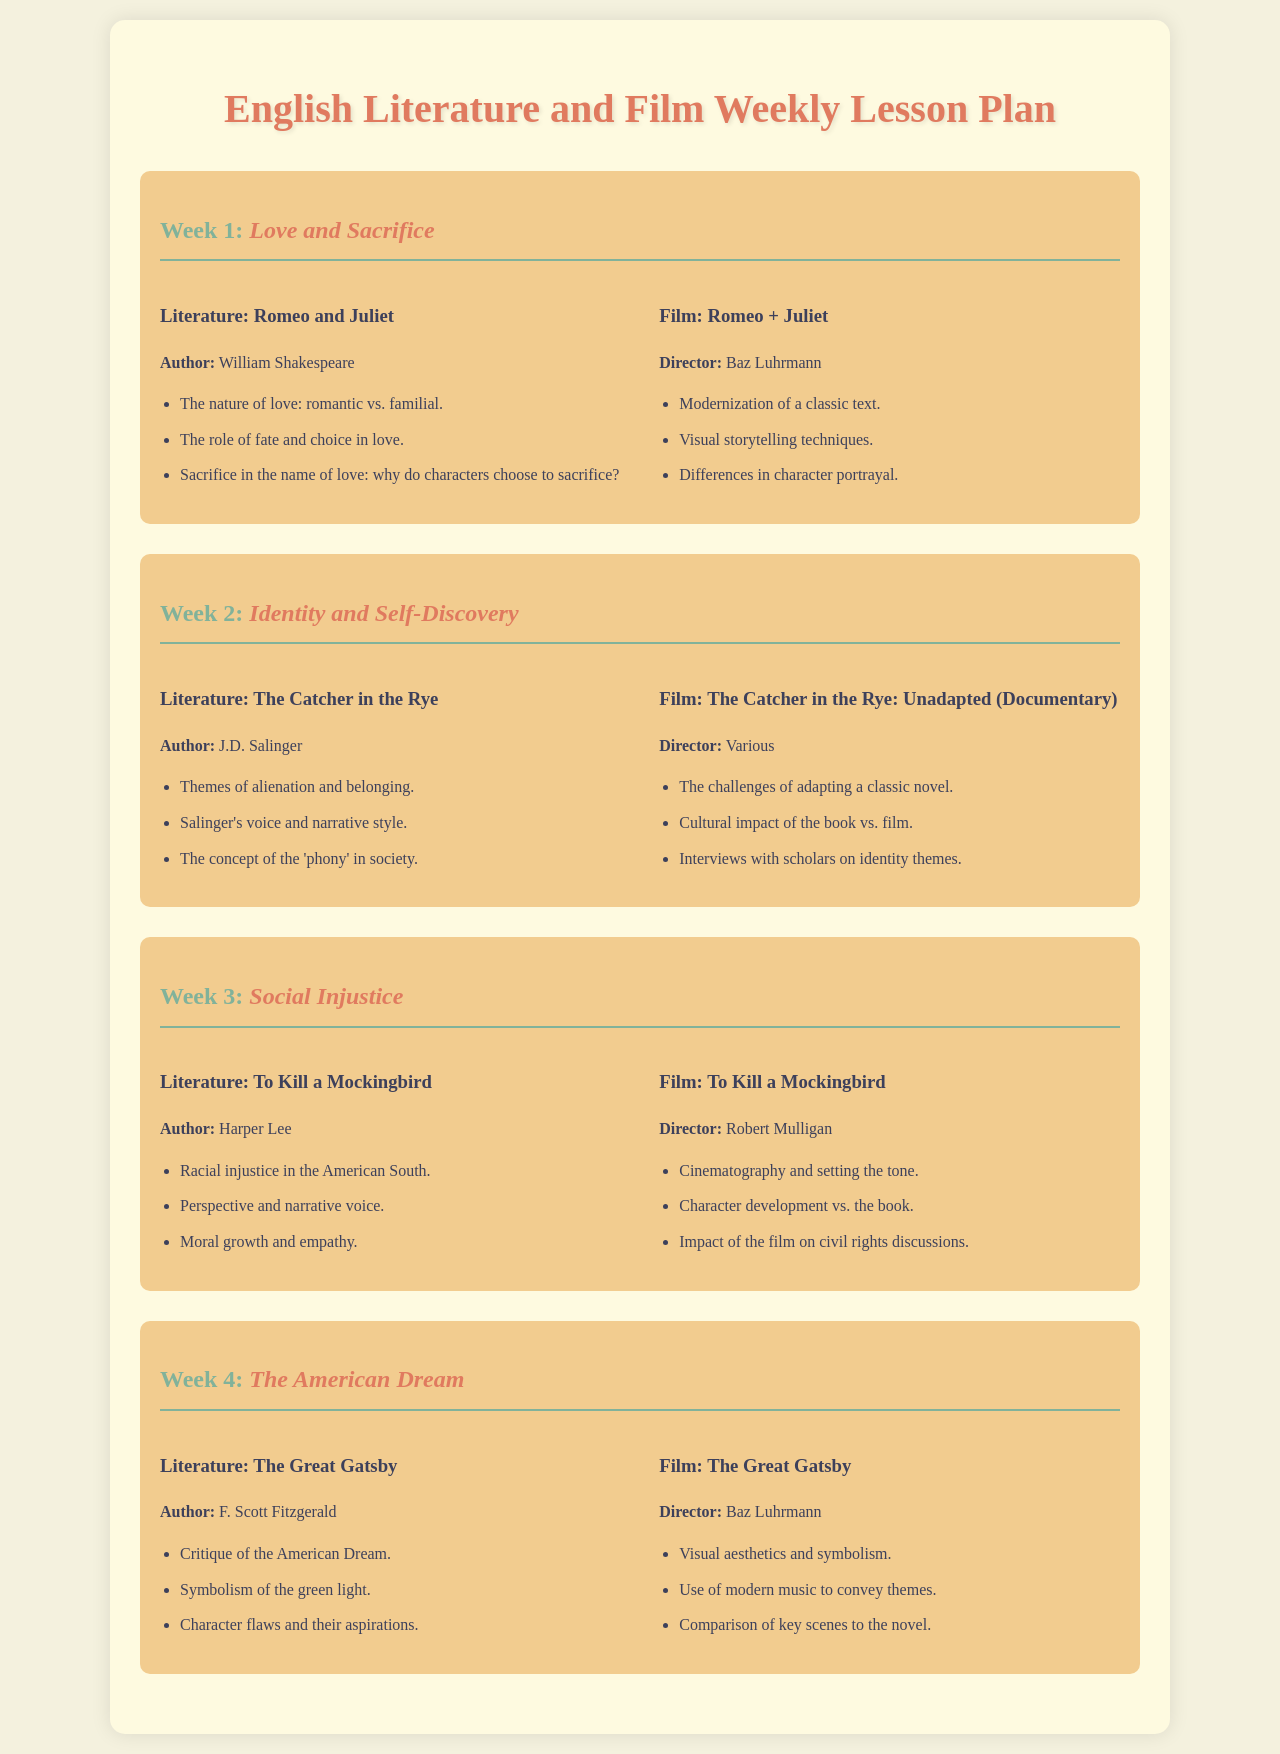What is the theme for Week 1? The theme for Week 1 is 'Love and Sacrifice' as stated in the document.
Answer: Love and Sacrifice Who is the author of "The Catcher in the Rye"? The author of "The Catcher in the Rye" is J.D. Salinger, mentioned in the literature section.
Answer: J.D. Salinger Which film is directed by Baz Luhrmann? The film directed by Baz Luhrmann is "The Great Gatsby" as listed under the film section.
Answer: The Great Gatsby What literary work addresses social injustice? The literary work that addresses social injustice is "To Kill a Mockingbird," highlighted in Week 3.
Answer: To Kill a Mockingbird How many weeks are covered in the lesson plan? The lesson plan covers a total of four weeks as outlined in the document.
Answer: Four weeks What is the main focus of the documentary film listed? The main focus of the documentary film is the challenges of adapting a classic novel, as stated under Week 2.
Answer: Challenges of adapting a classic novel Which literary piece critiques the American Dream? The literary piece that critiques the American Dream is "The Great Gatsby," detailed in Week 4.
Answer: The Great Gatsby What key theme is explored in Week 3's literature? The key theme explored in Week 3's literature is racial injustice, specifically mentioned in relation to "To Kill a Mockingbird."
Answer: Racial injustice Who directed the film adaptation of "Romeo and Juliet"? The director of the film adaptation of "Romeo and Juliet" is Baz Luhrmann as indicated in the document.
Answer: Baz Luhrmann 